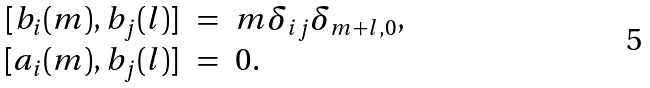Convert formula to latex. <formula><loc_0><loc_0><loc_500><loc_500>\begin{array} { r c l } \ [ b _ { i } ( m ) , b _ { j } ( l ) ] & = & m \delta _ { i j } \delta _ { m + l , 0 } , \\ \ [ a _ { i } ( m ) , b _ { j } ( l ) ] & = & 0 . \end{array}</formula> 